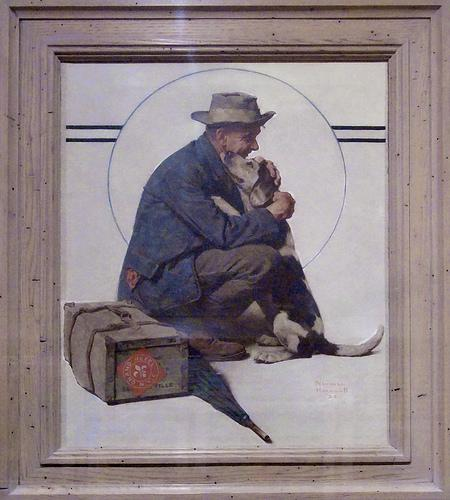Question: where is the camera pointed?
Choices:
A. At the people.
B. At a painting.
C. At the actor.
D. At the set.
Answer with the letter. Answer: B Question: how many men are in the painting?
Choices:
A. Two.
B. Three.
C. One.
D. Four.
Answer with the letter. Answer: C 